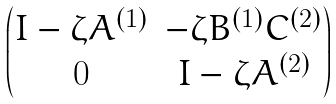<formula> <loc_0><loc_0><loc_500><loc_500>\begin{pmatrix} I - \zeta A ^ { ( 1 ) } & - \zeta B ^ { ( 1 ) } C ^ { ( 2 ) } \\ 0 & I - \zeta A ^ { ( 2 ) } \end{pmatrix}</formula> 